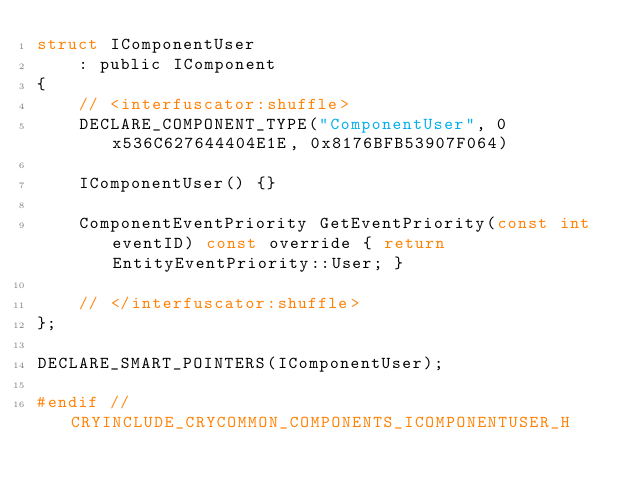<code> <loc_0><loc_0><loc_500><loc_500><_C_>struct IComponentUser
    : public IComponent
{
    // <interfuscator:shuffle>
    DECLARE_COMPONENT_TYPE("ComponentUser", 0x536C627644404E1E, 0x8176BFB53907F064)

    IComponentUser() {}

    ComponentEventPriority GetEventPriority(const int eventID) const override { return EntityEventPriority::User; }

    // </interfuscator:shuffle>
};

DECLARE_SMART_POINTERS(IComponentUser);

#endif // CRYINCLUDE_CRYCOMMON_COMPONENTS_ICOMPONENTUSER_H</code> 